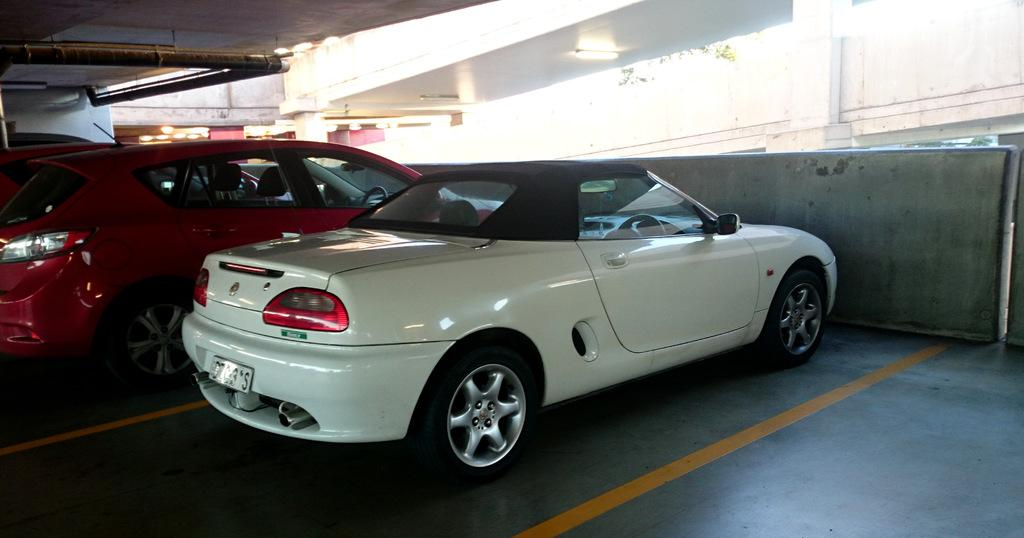What can be found in the cellar in the image? There are cars parked in the cellar. What is attached to the roof in the image? There is a pipe attached to the roof in the image. What is located on the right side top of the image? There is another building on the right side top of the image. What type of pear is hanging from the pipe in the image? There is no pear present in the image; it features cars parked in the cellar and a pipe attached to the roof. What is the reaction of the building on the right side top when the pipe is touched? There is no reaction of the building in the image, as it is a static image and does not depict any interactions or movements. 